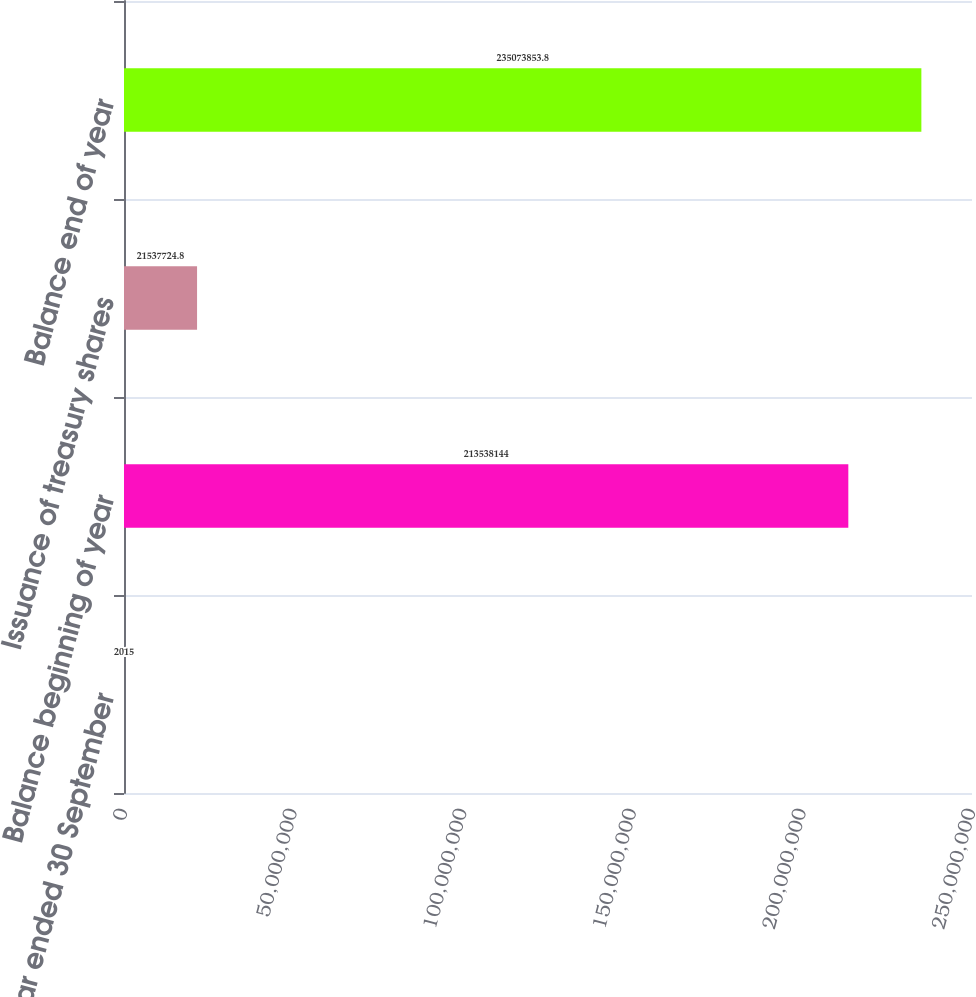Convert chart. <chart><loc_0><loc_0><loc_500><loc_500><bar_chart><fcel>Year ended 30 September<fcel>Balance beginning of year<fcel>Issuance of treasury shares<fcel>Balance end of year<nl><fcel>2015<fcel>2.13538e+08<fcel>2.15377e+07<fcel>2.35074e+08<nl></chart> 